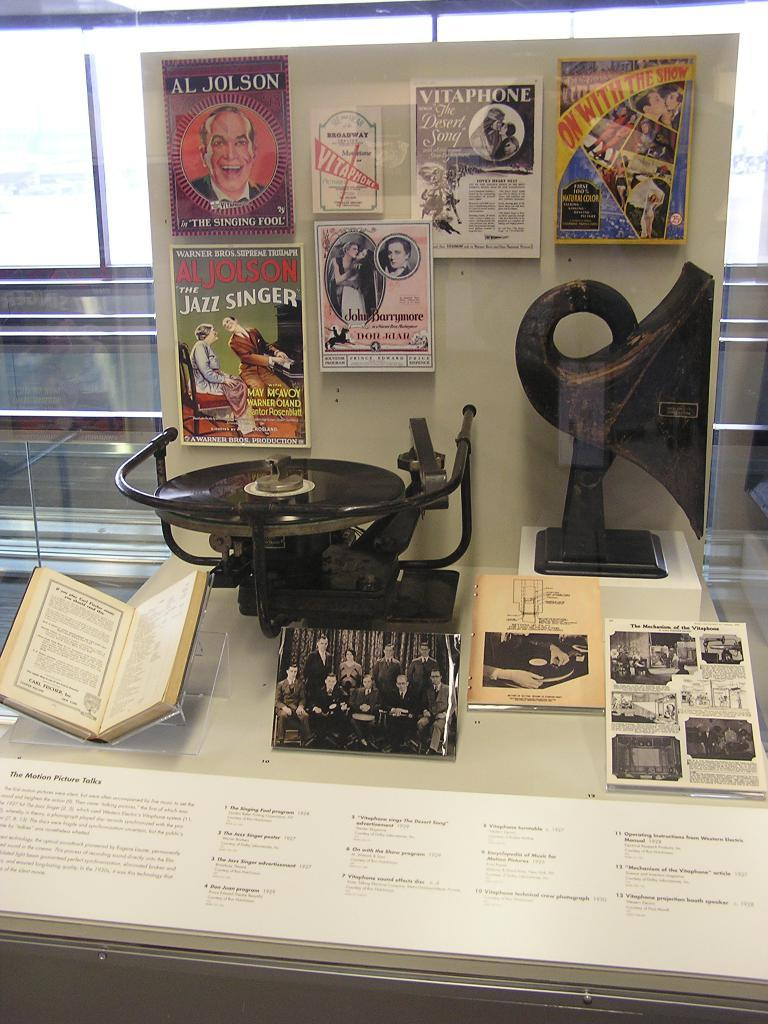<image>
Provide a brief description of the given image. A display case labeled "the motion picture talks" shows an old record player with various magazines. 